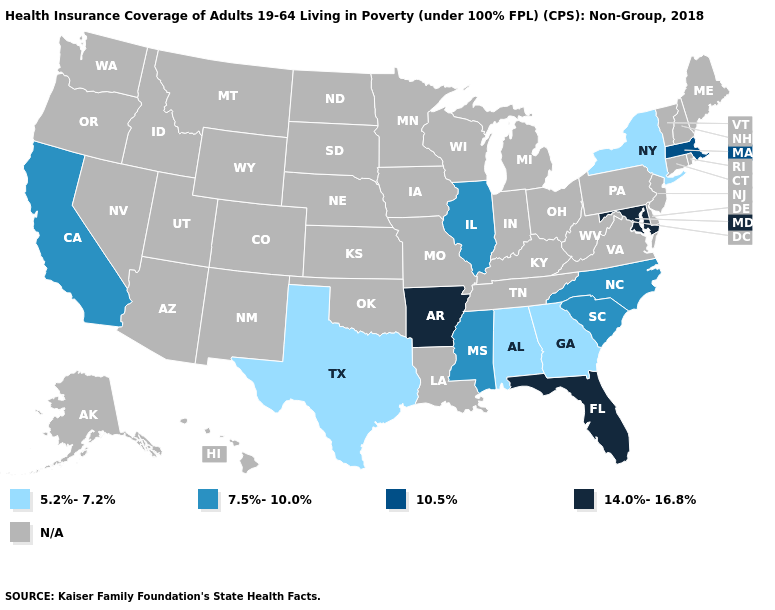What is the value of Indiana?
Concise answer only. N/A. Name the states that have a value in the range 7.5%-10.0%?
Concise answer only. California, Illinois, Mississippi, North Carolina, South Carolina. Name the states that have a value in the range N/A?
Short answer required. Alaska, Arizona, Colorado, Connecticut, Delaware, Hawaii, Idaho, Indiana, Iowa, Kansas, Kentucky, Louisiana, Maine, Michigan, Minnesota, Missouri, Montana, Nebraska, Nevada, New Hampshire, New Jersey, New Mexico, North Dakota, Ohio, Oklahoma, Oregon, Pennsylvania, Rhode Island, South Dakota, Tennessee, Utah, Vermont, Virginia, Washington, West Virginia, Wisconsin, Wyoming. What is the value of Louisiana?
Be succinct. N/A. Does New York have the lowest value in the USA?
Give a very brief answer. Yes. What is the value of Idaho?
Keep it brief. N/A. Name the states that have a value in the range 14.0%-16.8%?
Write a very short answer. Arkansas, Florida, Maryland. Name the states that have a value in the range 10.5%?
Write a very short answer. Massachusetts. Among the states that border New Hampshire , which have the highest value?
Keep it brief. Massachusetts. Among the states that border South Carolina , does Georgia have the highest value?
Be succinct. No. Which states hav the highest value in the South?
Short answer required. Arkansas, Florida, Maryland. Name the states that have a value in the range 5.2%-7.2%?
Concise answer only. Alabama, Georgia, New York, Texas. What is the highest value in the Northeast ?
Give a very brief answer. 10.5%. Name the states that have a value in the range 5.2%-7.2%?
Write a very short answer. Alabama, Georgia, New York, Texas. 